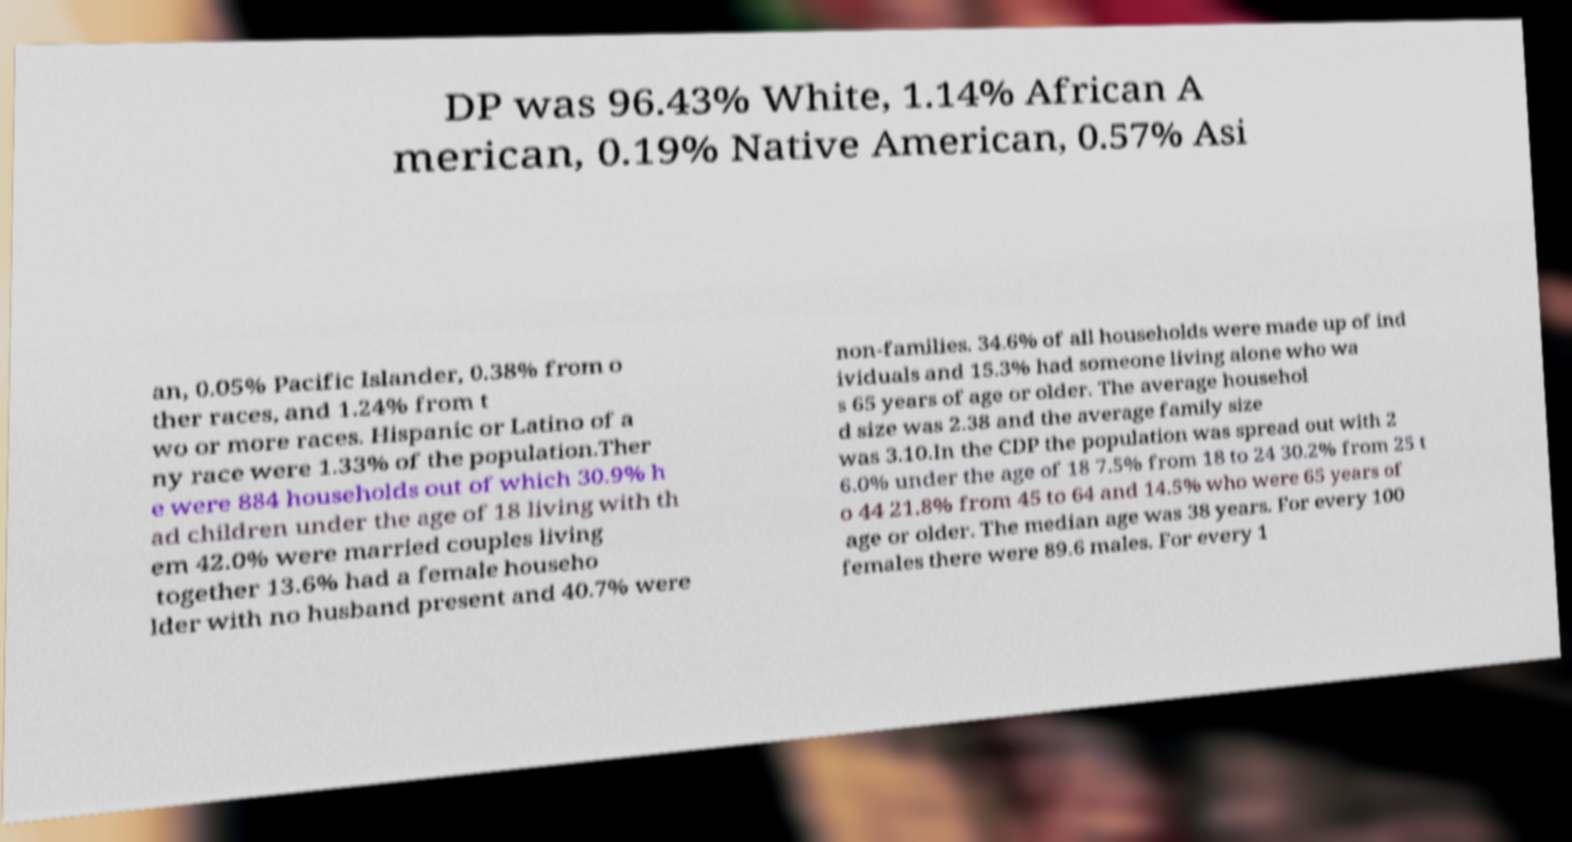There's text embedded in this image that I need extracted. Can you transcribe it verbatim? DP was 96.43% White, 1.14% African A merican, 0.19% Native American, 0.57% Asi an, 0.05% Pacific Islander, 0.38% from o ther races, and 1.24% from t wo or more races. Hispanic or Latino of a ny race were 1.33% of the population.Ther e were 884 households out of which 30.9% h ad children under the age of 18 living with th em 42.0% were married couples living together 13.6% had a female househo lder with no husband present and 40.7% were non-families. 34.6% of all households were made up of ind ividuals and 15.3% had someone living alone who wa s 65 years of age or older. The average househol d size was 2.38 and the average family size was 3.10.In the CDP the population was spread out with 2 6.0% under the age of 18 7.5% from 18 to 24 30.2% from 25 t o 44 21.8% from 45 to 64 and 14.5% who were 65 years of age or older. The median age was 38 years. For every 100 females there were 89.6 males. For every 1 